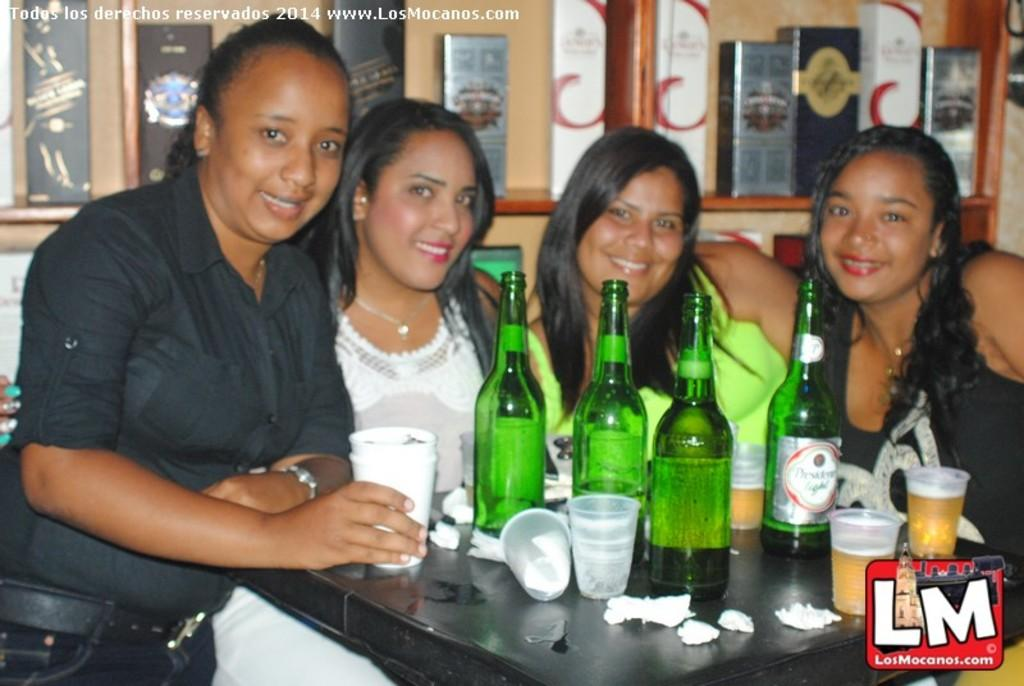How many women are present in the image? There are four women in the image. What are the women doing in the image? The women are standing near a table. What objects can be seen on the table? There is a glass, tissue, and wine bottles on the table. What is visible in the background of the image? There are boxes in racks in the background of the image. Can you see any seeds growing on the mountain in the image? There is no mountain or seeds present in the image. What type of balls are being used by the women in the image? There are no balls visible in the image; the women are standing near a table with glasses, tissue, and wine bottles. 